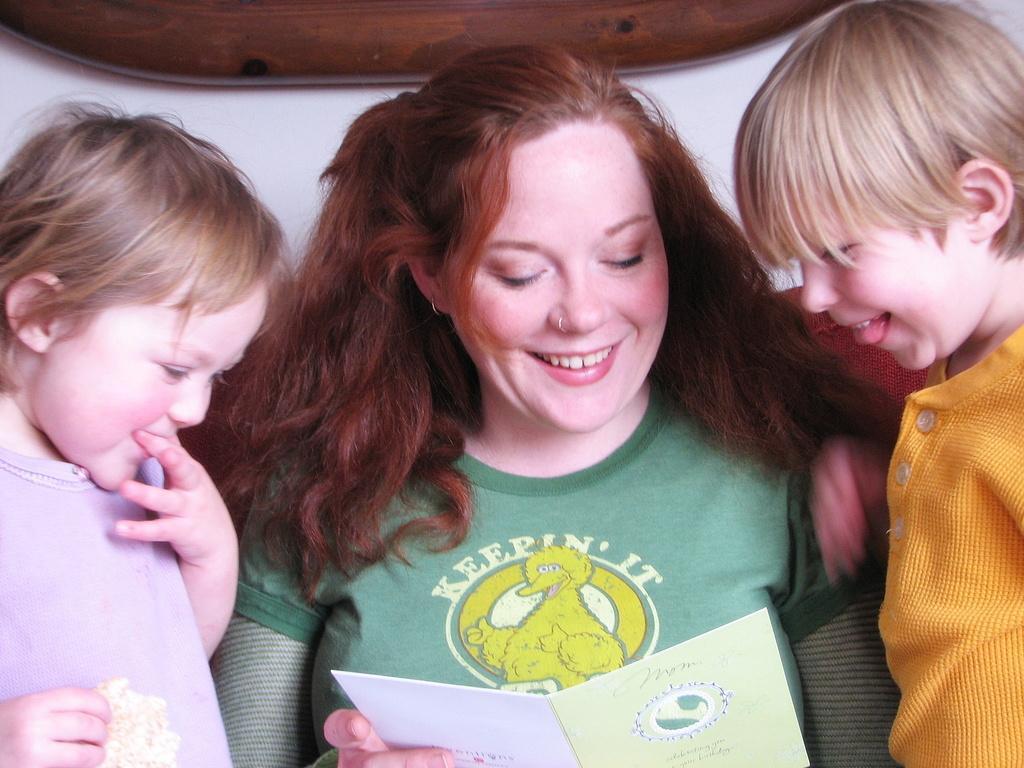In one or two sentences, can you explain what this image depicts? In this picture I can see two kids and a woman smiling , a woman holding a card, and in the background there is an wooden object. 